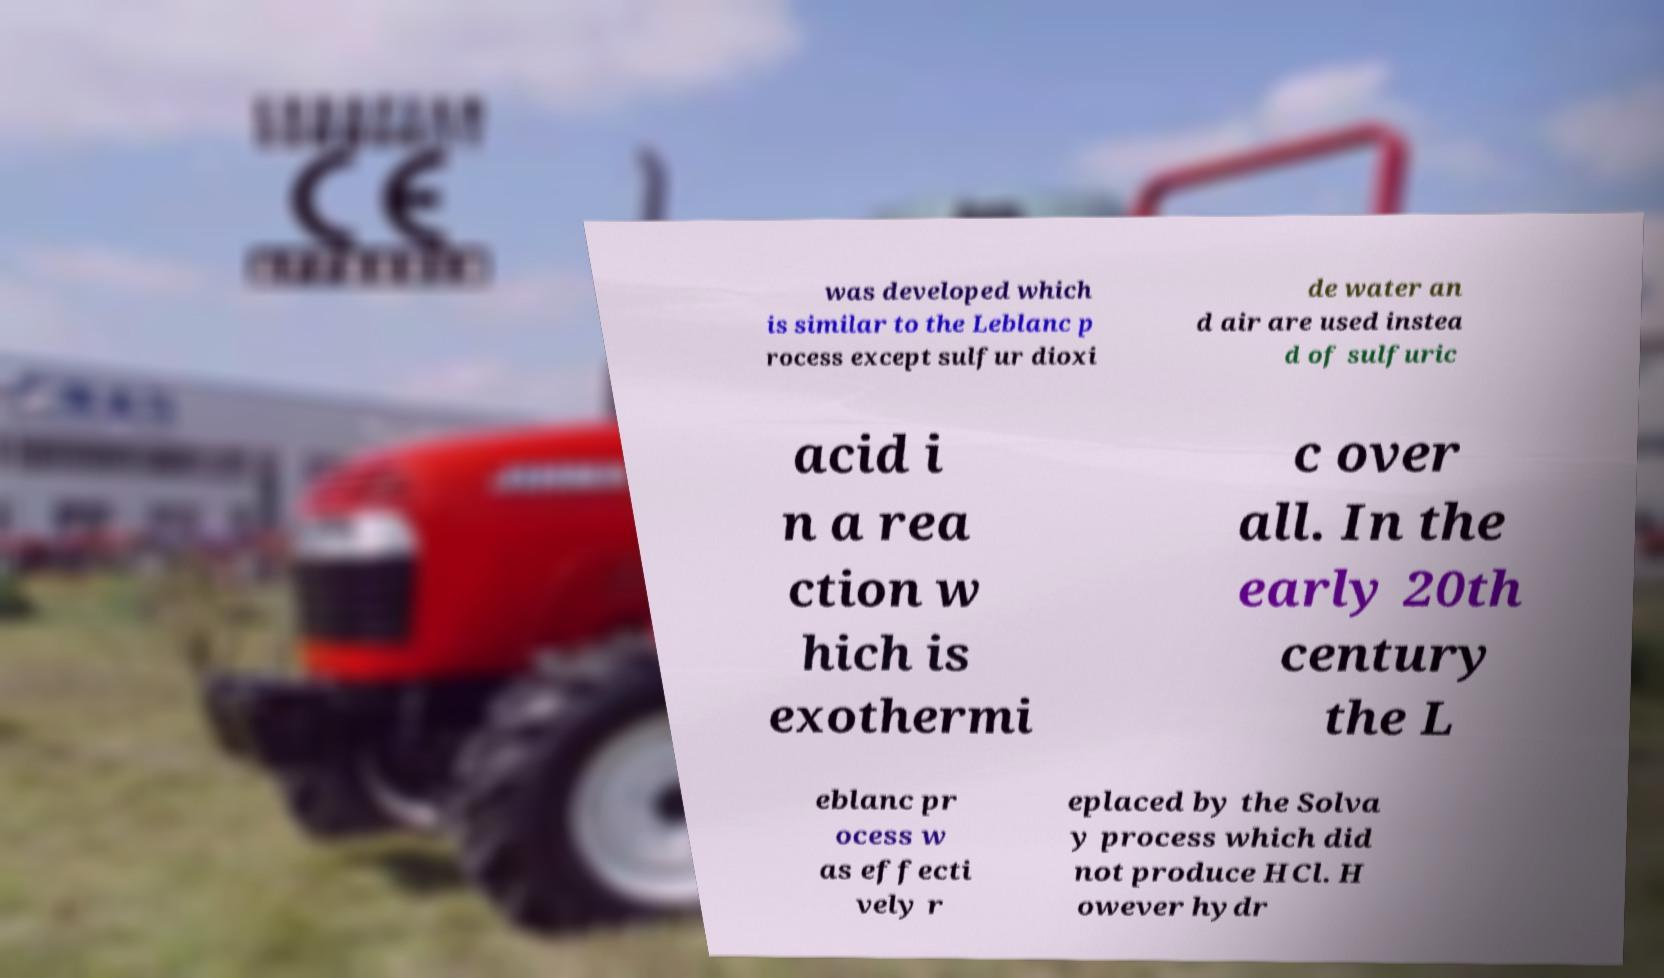Could you extract and type out the text from this image? was developed which is similar to the Leblanc p rocess except sulfur dioxi de water an d air are used instea d of sulfuric acid i n a rea ction w hich is exothermi c over all. In the early 20th century the L eblanc pr ocess w as effecti vely r eplaced by the Solva y process which did not produce HCl. H owever hydr 